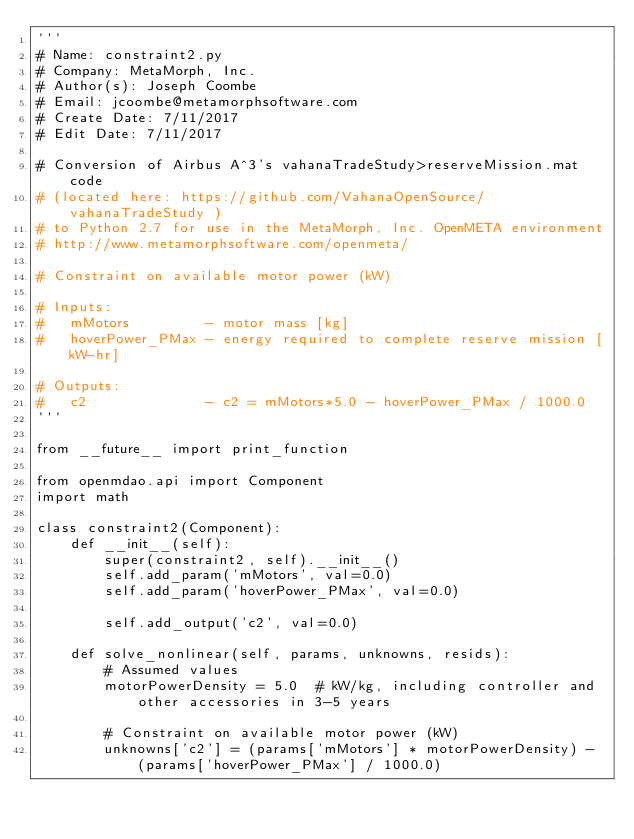<code> <loc_0><loc_0><loc_500><loc_500><_Python_>'''
# Name: constraint2.py
# Company: MetaMorph, Inc.
# Author(s): Joseph Coombe
# Email: jcoombe@metamorphsoftware.com
# Create Date: 7/11/2017
# Edit Date: 7/11/2017

# Conversion of Airbus A^3's vahanaTradeStudy>reserveMission.mat code
# (located here: https://github.com/VahanaOpenSource/vahanaTradeStudy )
# to Python 2.7 for use in the MetaMorph, Inc. OpenMETA environment
# http://www.metamorphsoftware.com/openmeta/

# Constraint on available motor power (kW)

# Inputs:
#   mMotors         - motor mass [kg]
#   hoverPower_PMax - energy required to complete reserve mission [kW-hr]

# Outputs:
#   c2              - c2 = mMotors*5.0 - hoverPower_PMax / 1000.0
'''

from __future__ import print_function

from openmdao.api import Component
import math

class constraint2(Component):
    def __init__(self):
        super(constraint2, self).__init__()
        self.add_param('mMotors', val=0.0)
        self.add_param('hoverPower_PMax', val=0.0)
        
        self.add_output('c2', val=0.0)
    
    def solve_nonlinear(self, params, unknowns, resids):
        # Assumed values
        motorPowerDensity = 5.0  # kW/kg, including controller and other accessories in 3-5 years
        
        # Constraint on available motor power (kW)
        unknowns['c2'] = (params['mMotors'] * motorPowerDensity) - (params['hoverPower_PMax'] / 1000.0) 
        </code> 